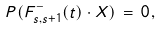<formula> <loc_0><loc_0><loc_500><loc_500>P ( F ^ { - } _ { s , s + 1 } ( t ) \cdot X ) \, = \, 0 \, ,</formula> 